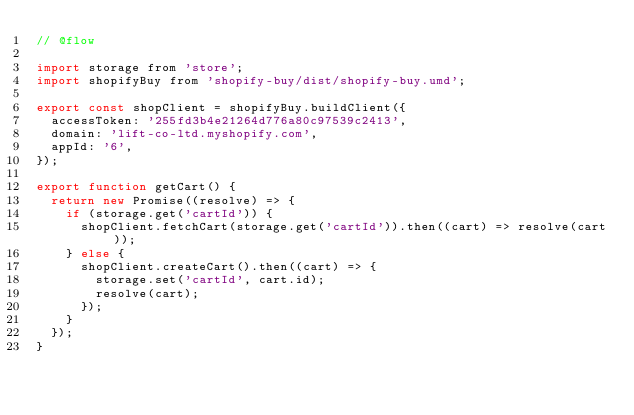Convert code to text. <code><loc_0><loc_0><loc_500><loc_500><_JavaScript_>// @flow

import storage from 'store';
import shopifyBuy from 'shopify-buy/dist/shopify-buy.umd';

export const shopClient = shopifyBuy.buildClient({
  accessToken: '255fd3b4e21264d776a80c97539c2413',
  domain: 'lift-co-ltd.myshopify.com',
  appId: '6',
});

export function getCart() {
  return new Promise((resolve) => {
    if (storage.get('cartId')) {
      shopClient.fetchCart(storage.get('cartId')).then((cart) => resolve(cart));
    } else {
      shopClient.createCart().then((cart) => {
        storage.set('cartId', cart.id);
        resolve(cart);
      });
    }
  });
}
</code> 